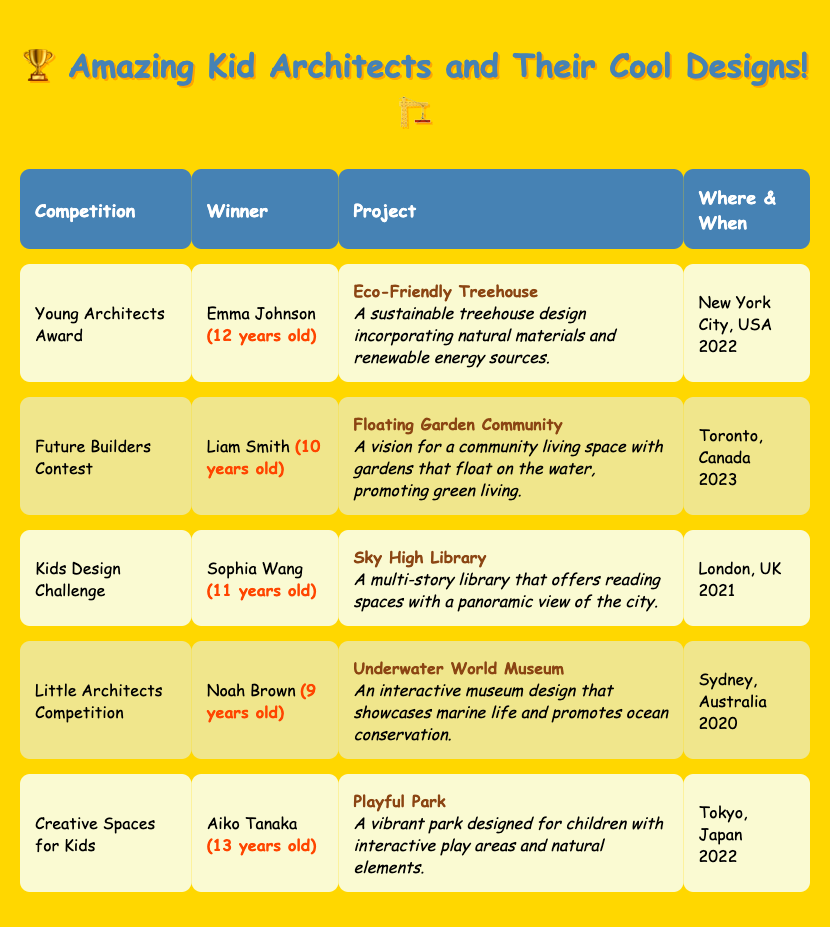What was the project title of the winner of the Young Architects Award? The winner of the Young Architects Award is Emma Johnson, and her project title is "Eco-Friendly Treehouse."
Answer: Eco-Friendly Treehouse Who won the Future Builders Contest, and how old were they? The Future Builders Contest was won by Liam Smith, who was 10 years old at the time.
Answer: Liam Smith, 10 years old Is the project "Sky High Library" related to a contest held in 2023? No, the "Sky High Library" was presented by Sophia Wang in the Kids Design Challenge, which took place in 2021, not 2023.
Answer: No How many contests were held in 2022? There are two contests held in 2022: the Young Architects Award and the Creative Spaces for Kids.
Answer: 2 What is the age difference between the youngest winner and the oldest winner? The youngest winner is Noah Brown, who was 9 years old, and the oldest winner is Aiko Tanaka, who was 13 years old. The difference is 13 - 9 = 4 years.
Answer: 4 years Which project has a focus on promoting green living? The project "Floating Garden Community" by Liam Smith promotes green living.
Answer: Floating Garden Community Where was the Little Architects Competition held? The Little Architects Competition was held in Sydney, Australia.
Answer: Sydney, Australia What year did Aiko Tanaka win their competition? Aiko Tanaka won the Creative Spaces for Kids competition in 2022.
Answer: 2022 What was the main theme of Noah Brown's project? Noah Brown's project, "Underwater World Museum," focused on showcasing marine life and promoting ocean conservation.
Answer: Showcasing marine life and ocean conservation Which competition had a project that incorporated renewable energy sources? The Young Architects Award featured a project titled "Eco-Friendly Treehouse," which incorporates renewable energy sources.
Answer: Young Architects Award 